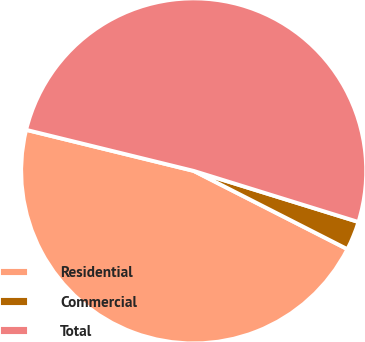<chart> <loc_0><loc_0><loc_500><loc_500><pie_chart><fcel>Residential<fcel>Commercial<fcel>Total<nl><fcel>46.33%<fcel>2.71%<fcel>50.96%<nl></chart> 